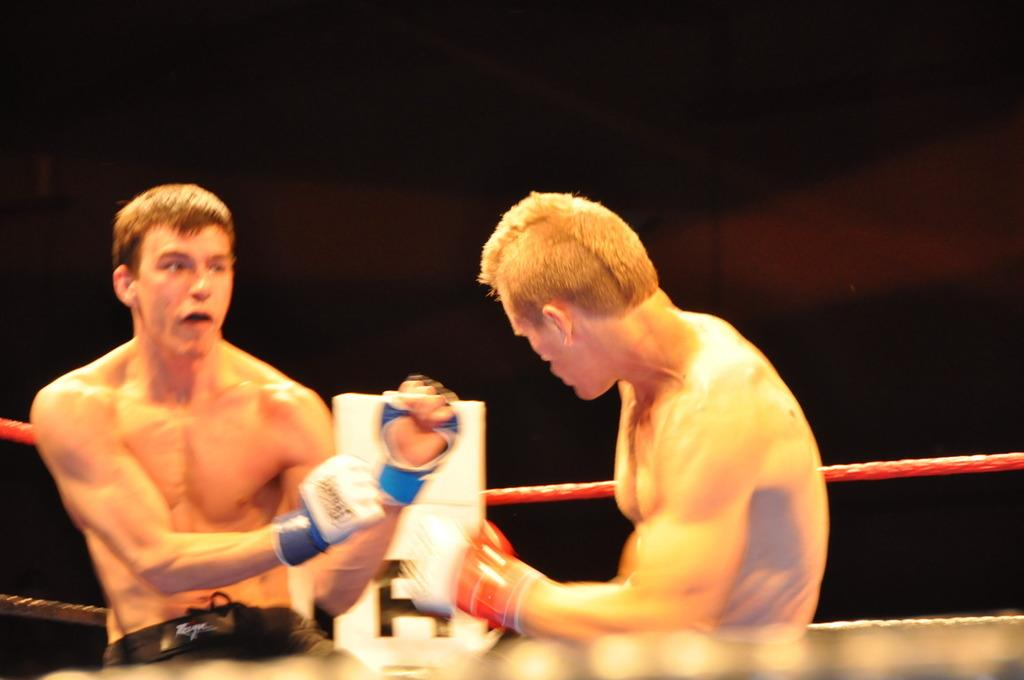How many people are present in the image? There are two people in the image. What is the main setting or structure in the image? There is a boxing ring in the image. Can you describe the color of any object in the image? There is a white colored object in the image. What can be observed about the lighting or color of the background in the image? The background of the image is dark. How many rabbits are hopping around in the image? There are no rabbits present in the image. What type of company is sponsoring the event in the image? There is no indication of any company sponsoring an event in the image. 